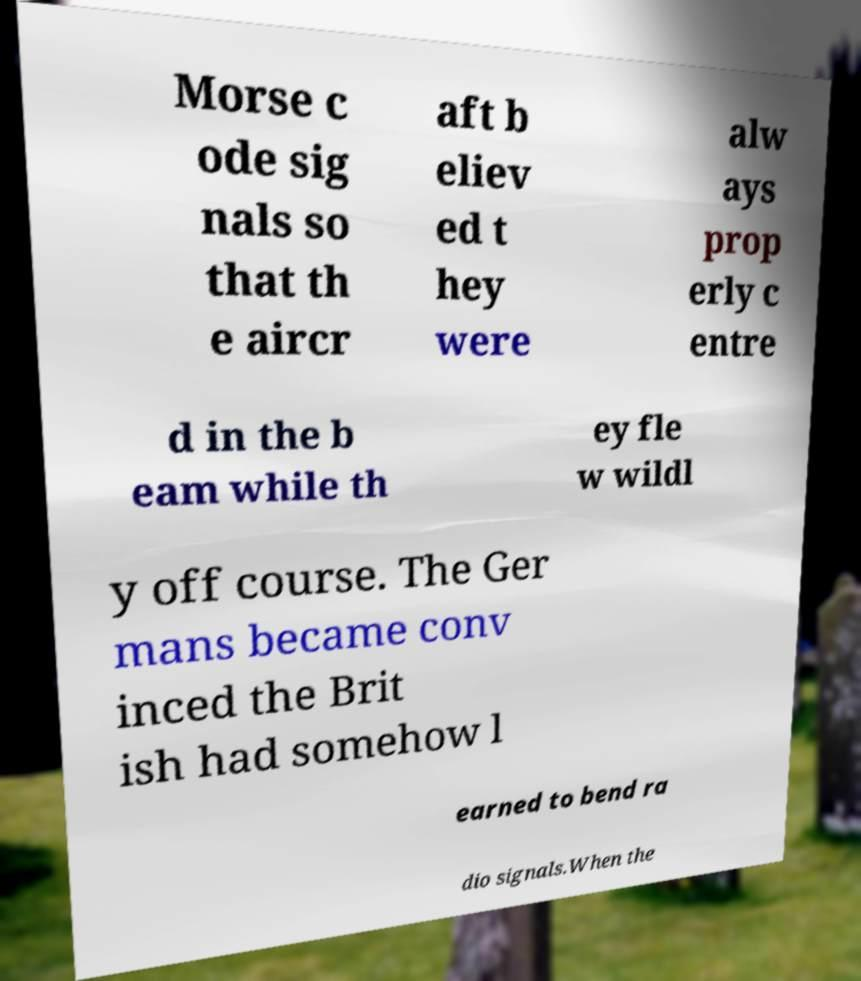Can you accurately transcribe the text from the provided image for me? Morse c ode sig nals so that th e aircr aft b eliev ed t hey were alw ays prop erly c entre d in the b eam while th ey fle w wildl y off course. The Ger mans became conv inced the Brit ish had somehow l earned to bend ra dio signals.When the 